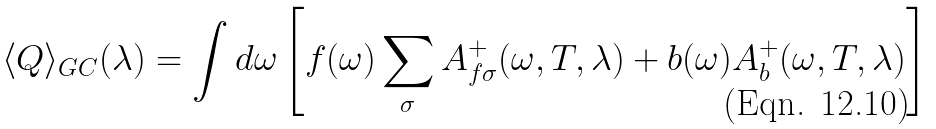<formula> <loc_0><loc_0><loc_500><loc_500>\langle Q \rangle _ { G C } ( \lambda ) = \int d \omega \left [ f ( \omega ) \sum _ { \sigma } A _ { f \sigma } ^ { + } ( \omega , T , \lambda ) + b ( \omega ) A _ { b } ^ { + } ( \omega , T , \lambda ) \right ]</formula> 